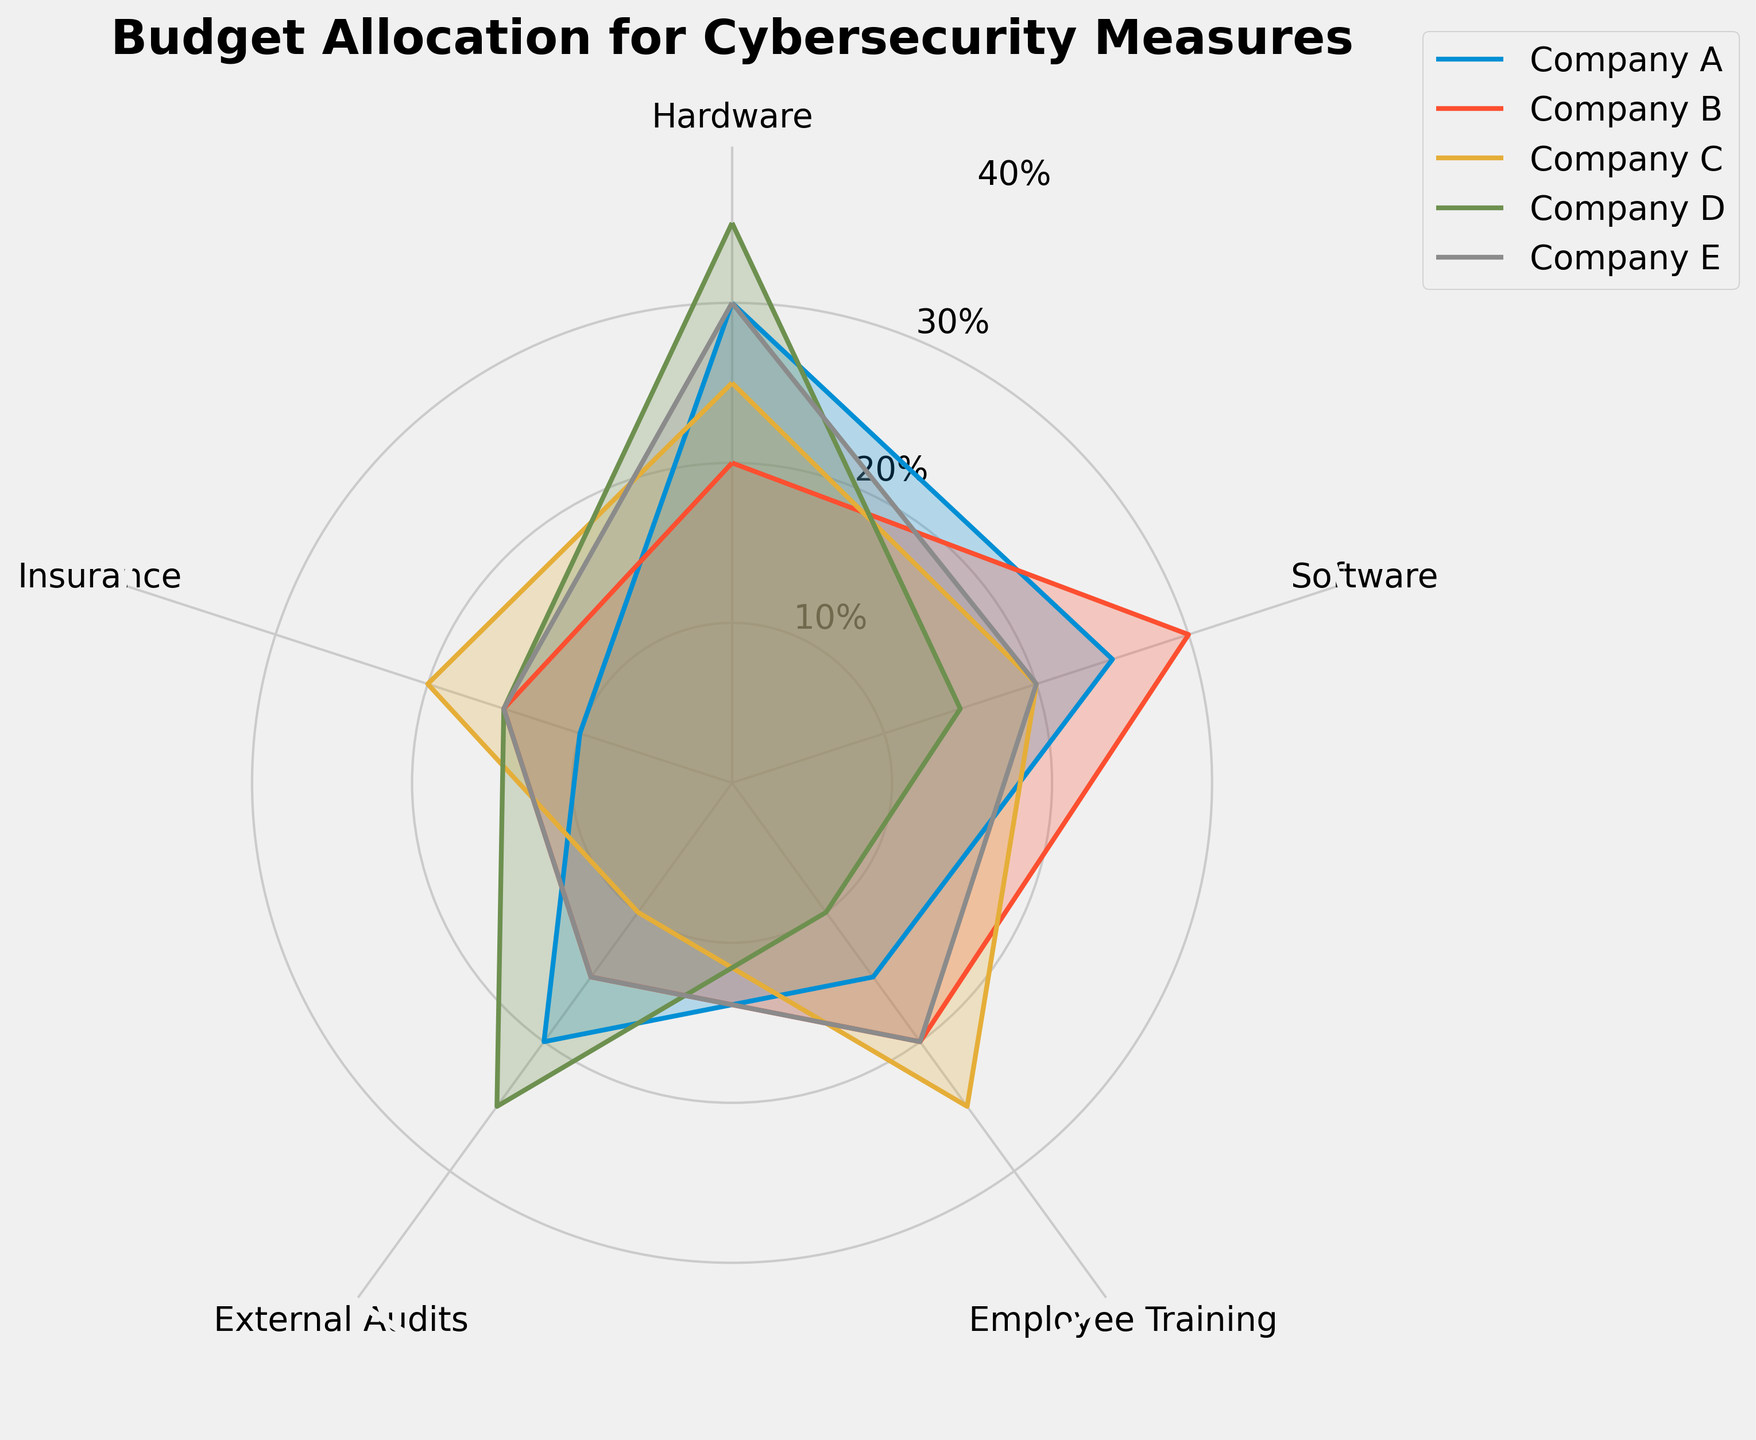Which company allocates the most budget to hardware? To determine the company with the highest budget for hardware, check the point on the hardware axis. Company D's plot extends the furthest, indicating the highest budget.
Answer: Company D Which company has the smallest proportion of their budget allocated to external audits? Check the external audits axis and look for the shortest line segment. Company C allocates the least.
Answer: Company C How much more does Company A allocate towards hardware compared to insurance? Compare the position of Company A’s plot on the hardware and insurance axes. Company A allocates 30% to hardware and 10% to insurance, so the difference is 20%.
Answer: 20% Rank the companies in terms of their budget for employee training from highest to lowest. For the employee training category, identify the lengths of the radar chart segments for all companies. Company C (25%), Company B and Company E (20%), Company A (15%), and Company D (10%).
Answer: Company C, Company B / Company E, Company A, Company D Which two companies have the same proportion of their budget allocated to insurance? Look at the insurance axis and identify which companies have the same length in their plot segments. Companies B, D, and E have identical percentages of 15%.
Answer: Companies B, D, and E What is the average proportion of the budget allocated to software across all companies? Add the software percentages for all companies: 25 + 30 + 20 + 15 + 20 = 110. Divide by the number of companies, which is 5. The average is 110 / 5 = 22%.
Answer: 22% Which category has the highest average budget allocation across all companies? For each category, sum the values and divide by the number of companies. Compare these averages: Hardware: (30+20+25+35+30)/5 = 28%, Software: (25+30+20+15+20)/5 = 22%, Employee Training: (15+20+25+10+20)/5 = 18%, External Audits: (20+15+10+25+15)/5 = 17%, Insurance: (10+15+20+15+15)/5 = 15%. Hardware has the highest average allocation.
Answer: Hardware Do any companies allocate equal budgets to hardware and software? Compare the segments for hardware and software for each company. No company shows equal allocation in these categories.
Answer: No Which company is most balanced in its budget allocation across all categories? The most balanced company would have the segments of similar lengths. Company E has the most balanced plot with segments ranging close to 20% (30, 20, 20, 15, 15).
Answer: Company E 